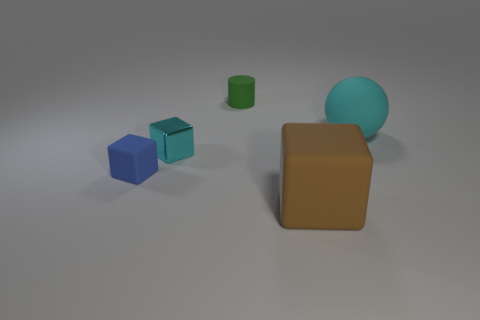What is the color of the big rubber object that is behind the brown object?
Offer a terse response. Cyan. There is a cyan thing to the left of the small matte cylinder; is its size the same as the matte block in front of the tiny blue rubber block?
Offer a terse response. No. How many things are either cyan matte objects or cubes?
Your answer should be very brief. 4. What material is the cyan thing that is to the right of the matte thing that is behind the large ball?
Give a very brief answer. Rubber. How many tiny metal things are the same shape as the cyan matte object?
Offer a very short reply. 0. Are there any small metallic blocks that have the same color as the ball?
Provide a succinct answer. Yes. How many objects are matte objects that are in front of the matte sphere or matte objects in front of the big cyan thing?
Provide a short and direct response. 2. There is a tiny rubber thing on the right side of the tiny cyan cube; are there any things that are in front of it?
Ensure brevity in your answer.  Yes. The other thing that is the same size as the cyan rubber object is what shape?
Your response must be concise. Cube. How many objects are either tiny matte things in front of the big cyan rubber ball or green cylinders?
Offer a terse response. 2. 